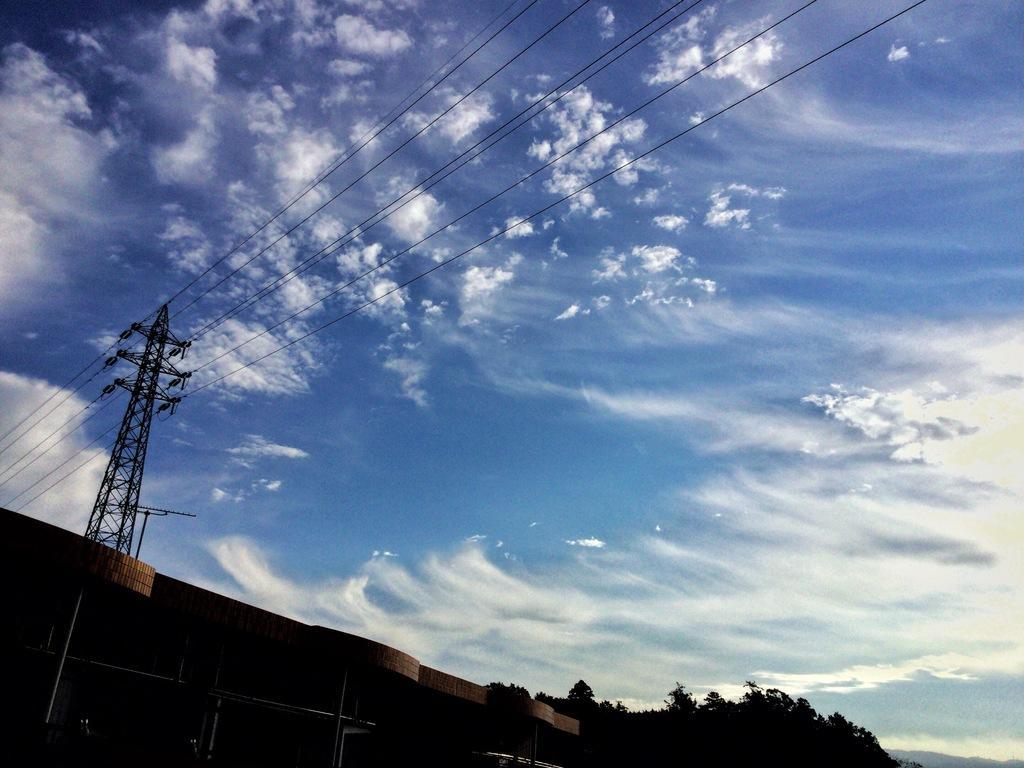Please provide a concise description of this image. In this image we can see some trees, wires, building and a tower, also we can see the sky with clouds. 